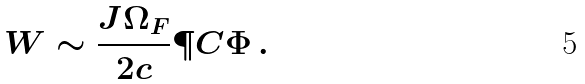<formula> <loc_0><loc_0><loc_500><loc_500>W \sim \frac { J \Omega _ { F } } { 2 c } \P C { \Phi } \, .</formula> 